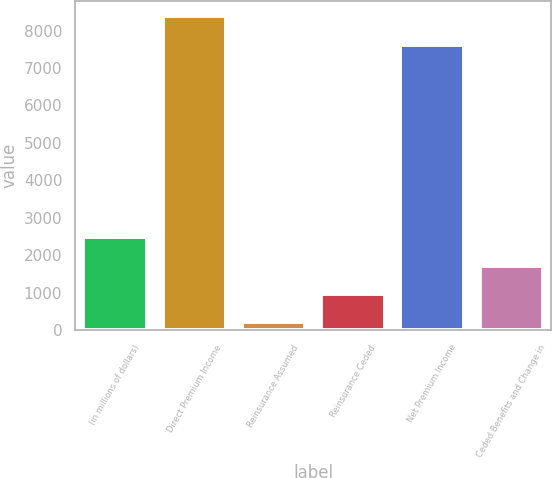Convert chart. <chart><loc_0><loc_0><loc_500><loc_500><bar_chart><fcel>(in millions of dollars)<fcel>Direct Premium Income<fcel>Reinsurance Assumed<fcel>Reinsurance Ceded<fcel>Net Premium Income<fcel>Ceded Benefits and Change in<nl><fcel>2475.43<fcel>8382.11<fcel>203.2<fcel>960.61<fcel>7624.7<fcel>1718.02<nl></chart> 